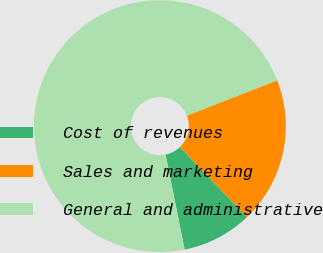Convert chart to OTSL. <chart><loc_0><loc_0><loc_500><loc_500><pie_chart><fcel>Cost of revenues<fcel>Sales and marketing<fcel>General and administrative<nl><fcel>9.01%<fcel>18.77%<fcel>72.22%<nl></chart> 